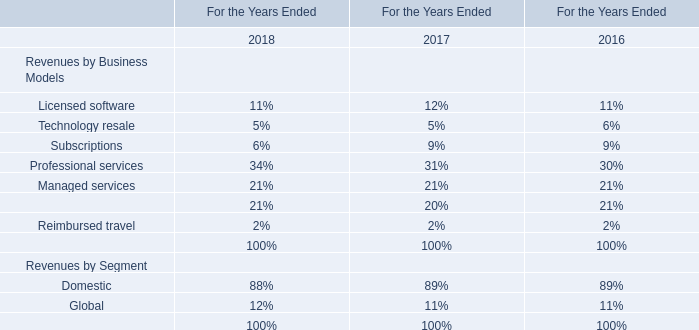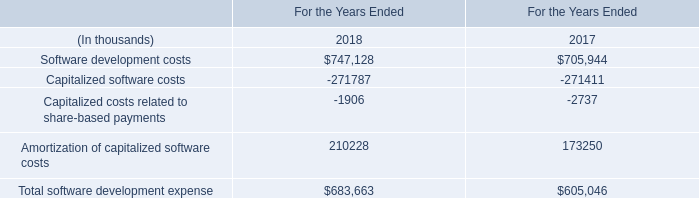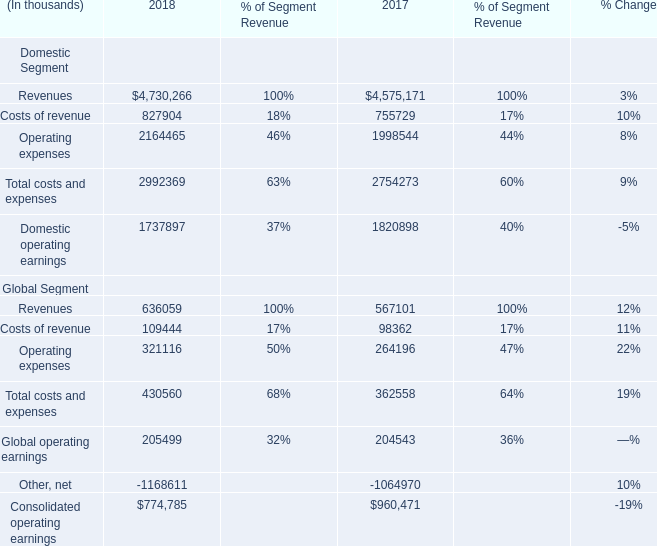what's the total amount of Consolidated operating earnings Global Segment of 2018, Capitalized software costs of For the Years Ended 2018, and Domestic operating earnings of 2017 ? 
Computations: ((774785.0 + 271787.0) + 1820898.0)
Answer: 2867470.0. 